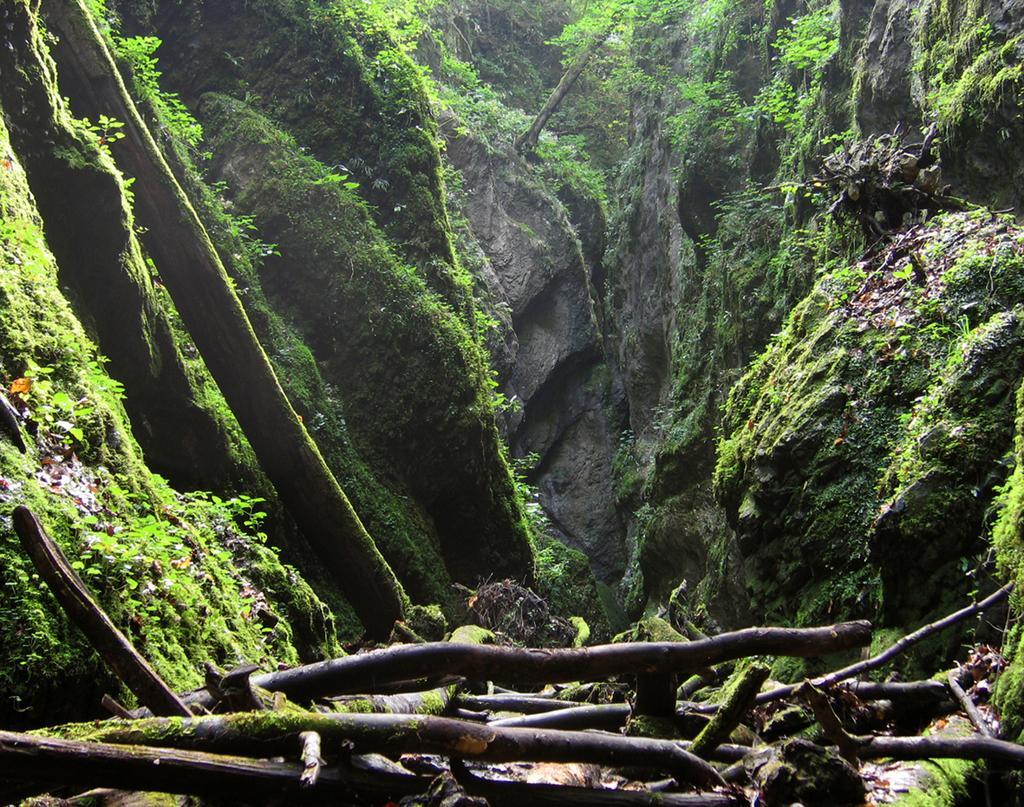Describe this image in one or two sentences. In this picture we can see wooden objects, plants, algae and rocks. 